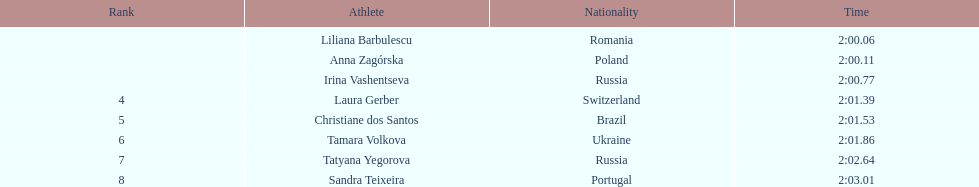Anna zagorska recieved 2nd place, what was her time? 2:00.11. 